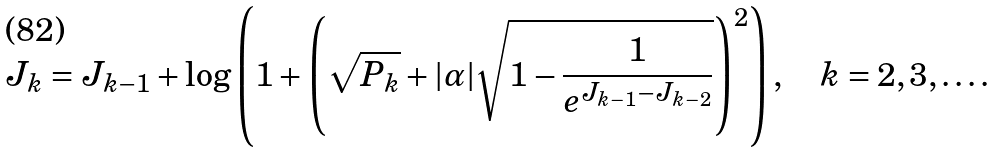<formula> <loc_0><loc_0><loc_500><loc_500>J _ { k } & = J _ { k - 1 } + \log \left ( 1 + \left ( \sqrt { P _ { k } } + | \alpha | \sqrt { 1 - \frac { 1 } { e ^ { J _ { k - 1 } - J _ { k - 2 } } } } \right ) ^ { 2 } \right ) , \quad k = 2 , 3 , \dots .</formula> 